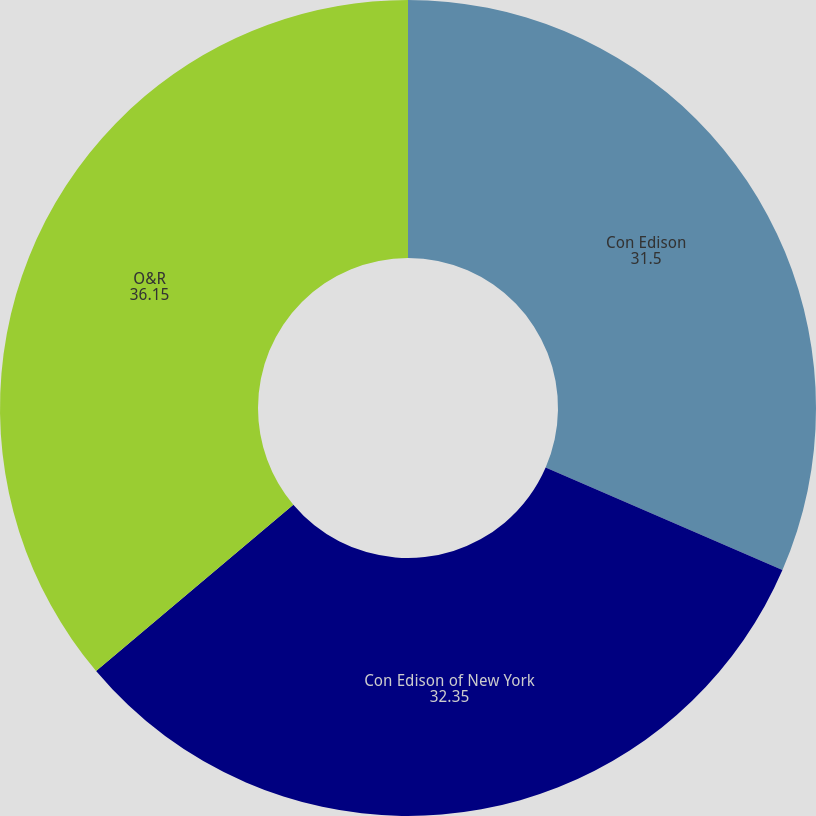<chart> <loc_0><loc_0><loc_500><loc_500><pie_chart><fcel>Con Edison<fcel>Con Edison of New York<fcel>O&R<nl><fcel>31.5%<fcel>32.35%<fcel>36.15%<nl></chart> 